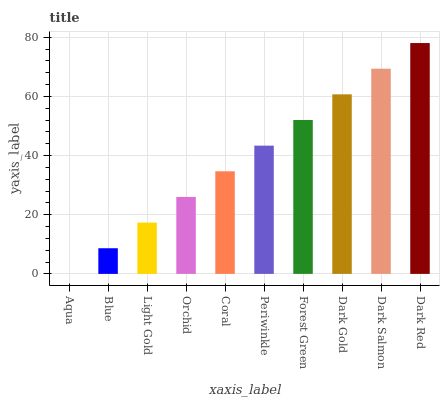Is Aqua the minimum?
Answer yes or no. Yes. Is Dark Red the maximum?
Answer yes or no. Yes. Is Blue the minimum?
Answer yes or no. No. Is Blue the maximum?
Answer yes or no. No. Is Blue greater than Aqua?
Answer yes or no. Yes. Is Aqua less than Blue?
Answer yes or no. Yes. Is Aqua greater than Blue?
Answer yes or no. No. Is Blue less than Aqua?
Answer yes or no. No. Is Periwinkle the high median?
Answer yes or no. Yes. Is Coral the low median?
Answer yes or no. Yes. Is Dark Red the high median?
Answer yes or no. No. Is Light Gold the low median?
Answer yes or no. No. 